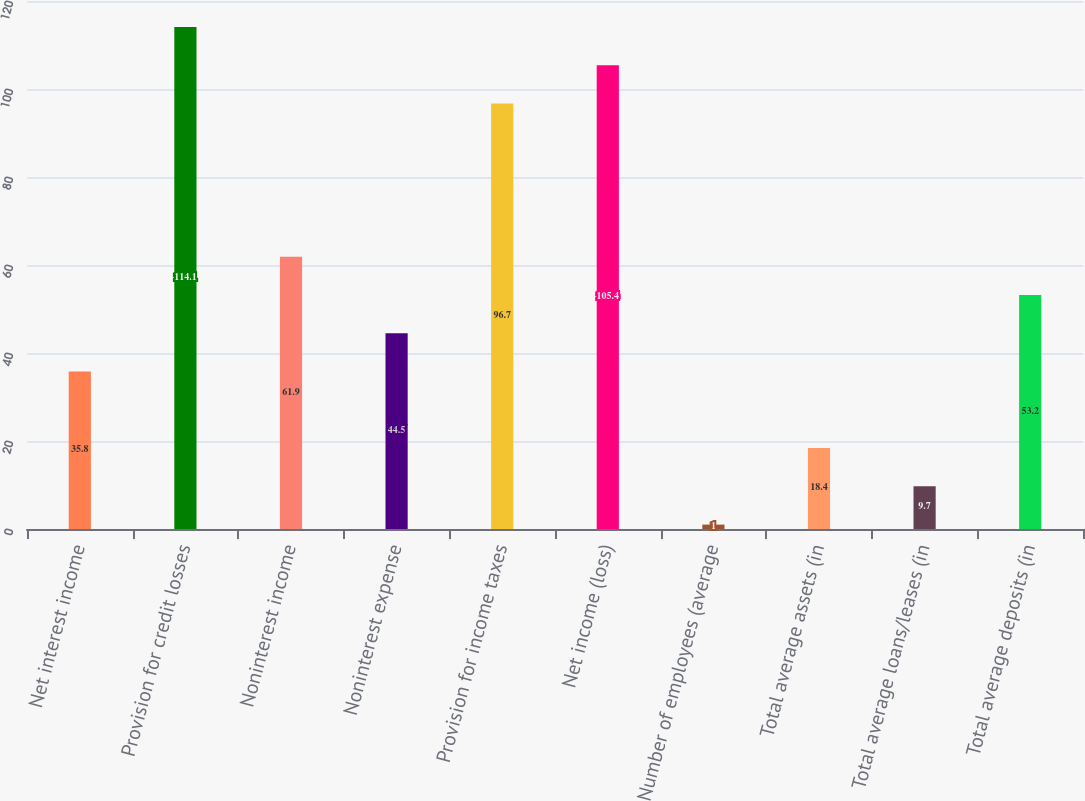Convert chart. <chart><loc_0><loc_0><loc_500><loc_500><bar_chart><fcel>Net interest income<fcel>Provision for credit losses<fcel>Noninterest income<fcel>Noninterest expense<fcel>Provision for income taxes<fcel>Net income (loss)<fcel>Number of employees (average<fcel>Total average assets (in<fcel>Total average loans/leases (in<fcel>Total average deposits (in<nl><fcel>35.8<fcel>114.1<fcel>61.9<fcel>44.5<fcel>96.7<fcel>105.4<fcel>1<fcel>18.4<fcel>9.7<fcel>53.2<nl></chart> 